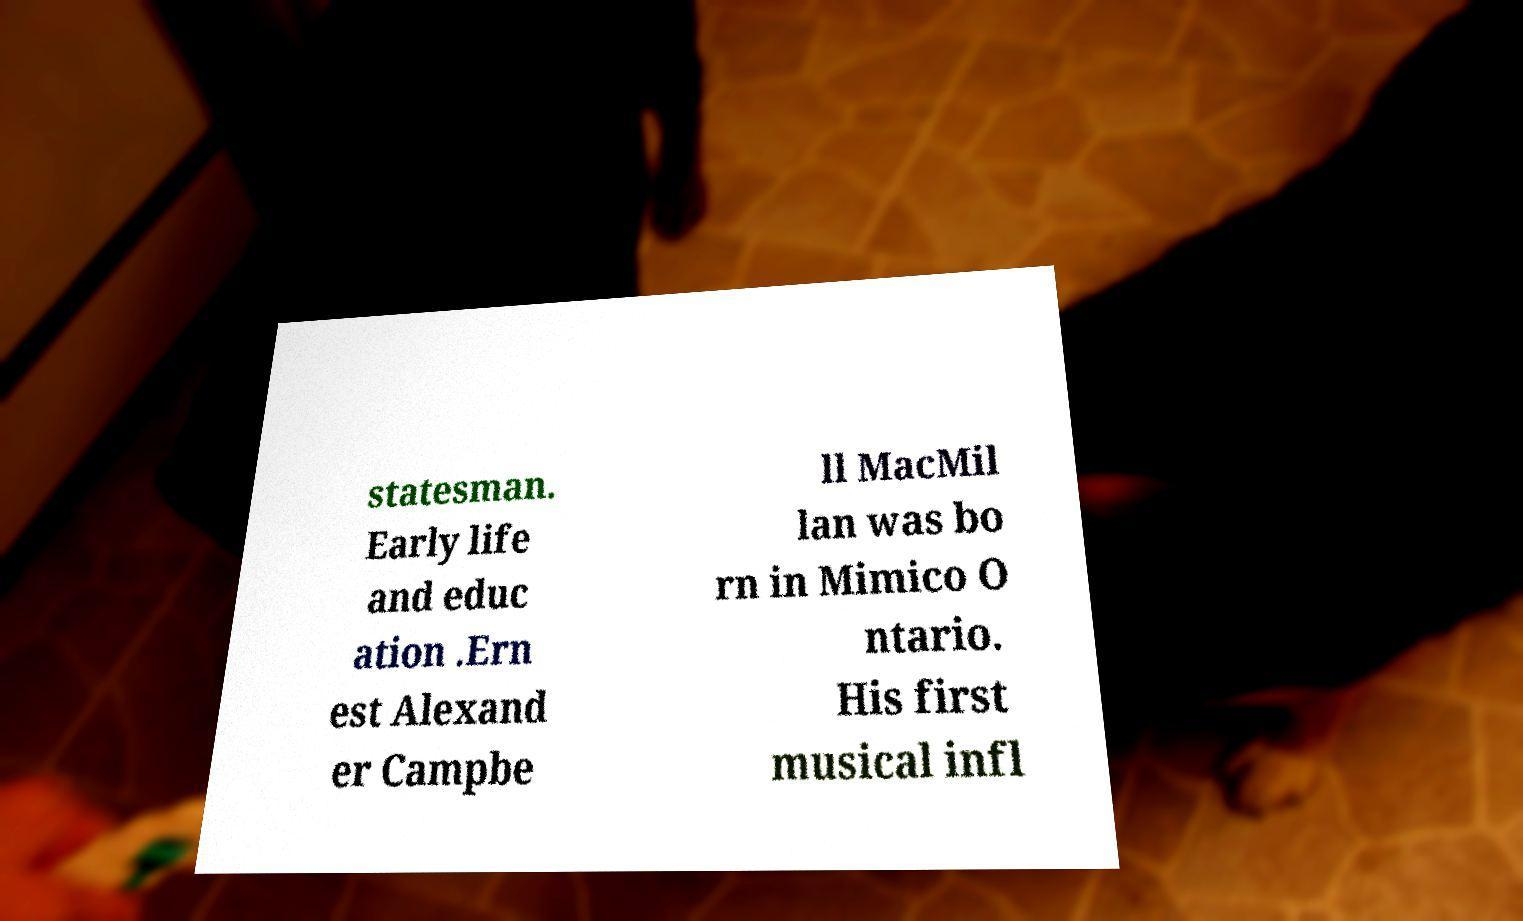Please identify and transcribe the text found in this image. statesman. Early life and educ ation .Ern est Alexand er Campbe ll MacMil lan was bo rn in Mimico O ntario. His first musical infl 